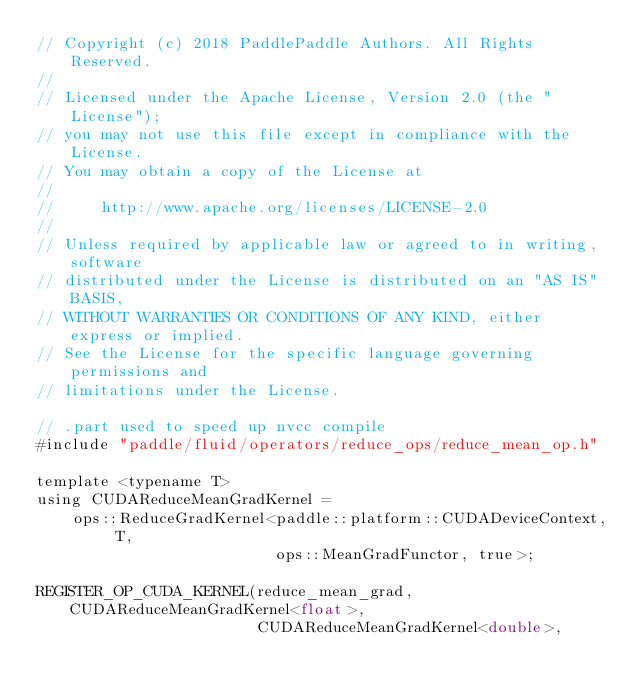Convert code to text. <code><loc_0><loc_0><loc_500><loc_500><_Cuda_>// Copyright (c) 2018 PaddlePaddle Authors. All Rights Reserved.
//
// Licensed under the Apache License, Version 2.0 (the "License");
// you may not use this file except in compliance with the License.
// You may obtain a copy of the License at
//
//     http://www.apache.org/licenses/LICENSE-2.0
//
// Unless required by applicable law or agreed to in writing, software
// distributed under the License is distributed on an "AS IS" BASIS,
// WITHOUT WARRANTIES OR CONDITIONS OF ANY KIND, either express or implied.
// See the License for the specific language governing permissions and
// limitations under the License.

// .part used to speed up nvcc compile
#include "paddle/fluid/operators/reduce_ops/reduce_mean_op.h"

template <typename T>
using CUDAReduceMeanGradKernel =
    ops::ReduceGradKernel<paddle::platform::CUDADeviceContext, T,
                          ops::MeanGradFunctor, true>;

REGISTER_OP_CUDA_KERNEL(reduce_mean_grad, CUDAReduceMeanGradKernel<float>,
                        CUDAReduceMeanGradKernel<double>,</code> 